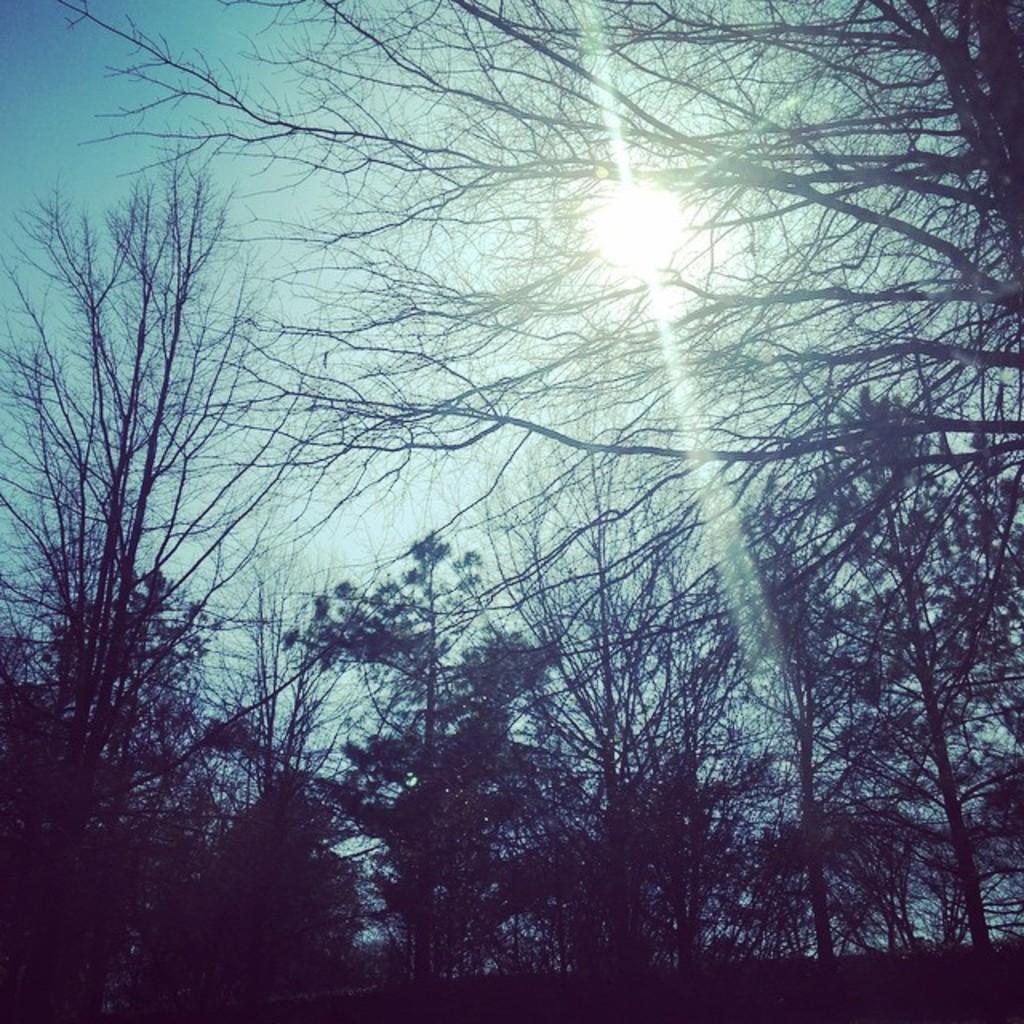How would you summarize this image in a sentence or two? In the middle of the image we can see some trees. Behind the trees we can see sun in the sky. 